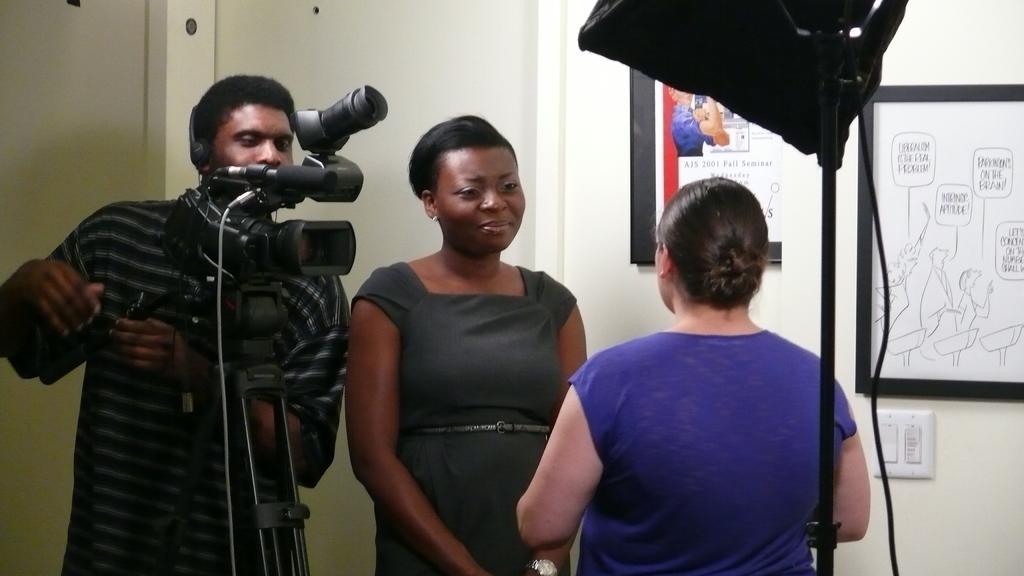Can you describe this image briefly? In this image, we can see people standing and one of them is wearing a headset and we can see a camera stand and an umbrella stand and some wires. In the background, there are frames on the wall and there is a board. 